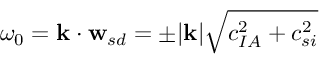Convert formula to latex. <formula><loc_0><loc_0><loc_500><loc_500>\omega _ { 0 } = k \cdot w _ { s d } = \pm | k | \sqrt { c _ { I A } ^ { 2 } + c _ { s i } ^ { 2 } }</formula> 